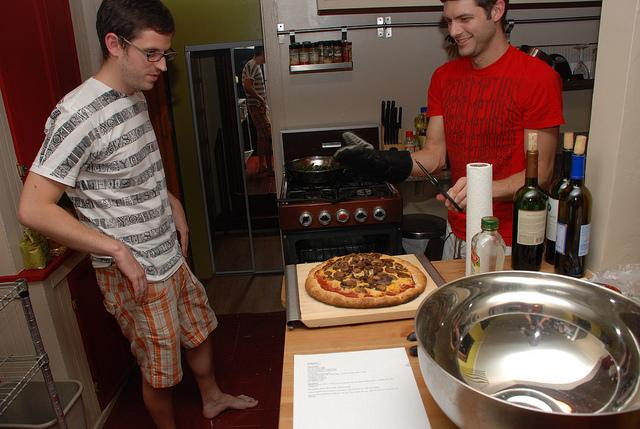Are they in a restaurant?
Be succinct. No. What are the people looking at?
Keep it brief. Pizza. How old does one need to be to drink the beverages in the bottles?
Write a very short answer. 21. 